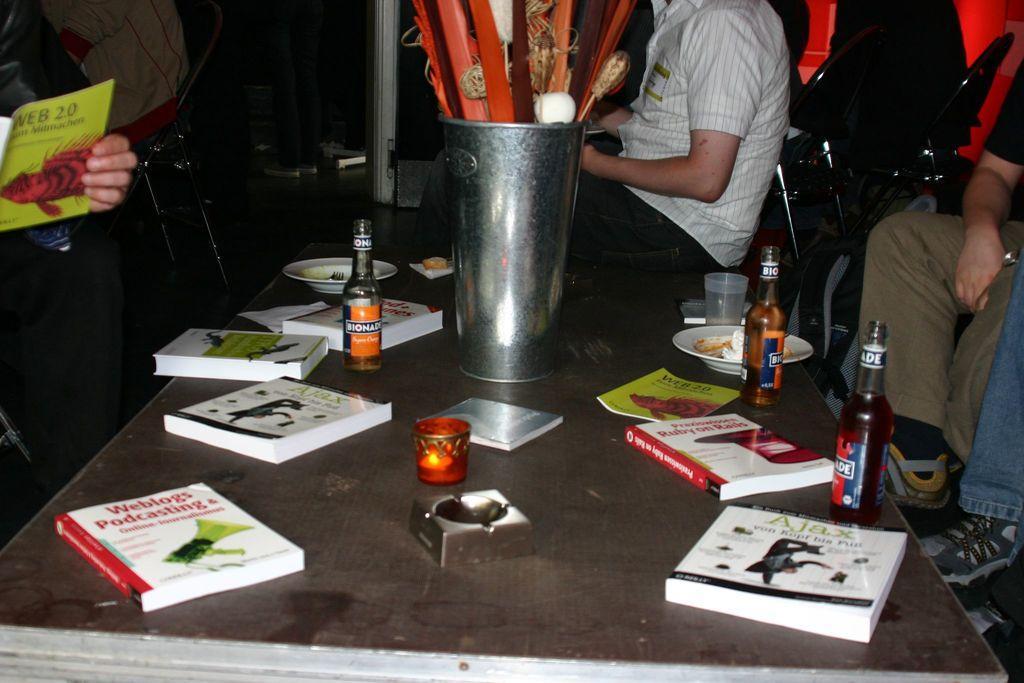In one or two sentences, can you explain what this image depicts? This image consists of a table and on that table there are so many books and bottles. There are people around this table. 